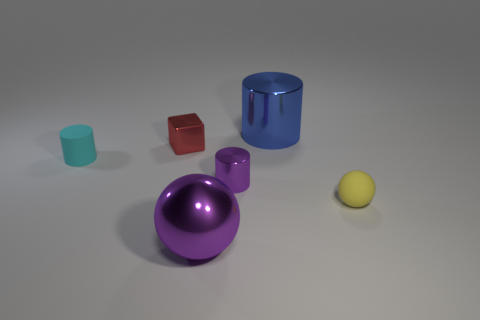There is a blue object that is the same shape as the small purple thing; what material is it?
Make the answer very short. Metal. How many metal objects are small purple cylinders or large blue things?
Ensure brevity in your answer.  2. There is a rubber thing that is on the right side of the large object on the left side of the cylinder behind the cyan object; what color is it?
Your answer should be very brief. Yellow. What number of other objects are the same material as the small yellow thing?
Your answer should be very brief. 1. Is the shape of the small matte object that is on the left side of the large cylinder the same as  the small yellow object?
Offer a very short reply. No. What number of large things are red rubber cylinders or red metal cubes?
Offer a terse response. 0. Are there an equal number of matte spheres on the left side of the yellow object and tiny red metal cubes behind the shiny block?
Give a very brief answer. Yes. How many other things are there of the same color as the tiny rubber cylinder?
Give a very brief answer. 0. There is a shiny ball; does it have the same color as the ball to the right of the tiny purple object?
Make the answer very short. No. How many purple objects are either balls or shiny objects?
Your answer should be very brief. 2. 